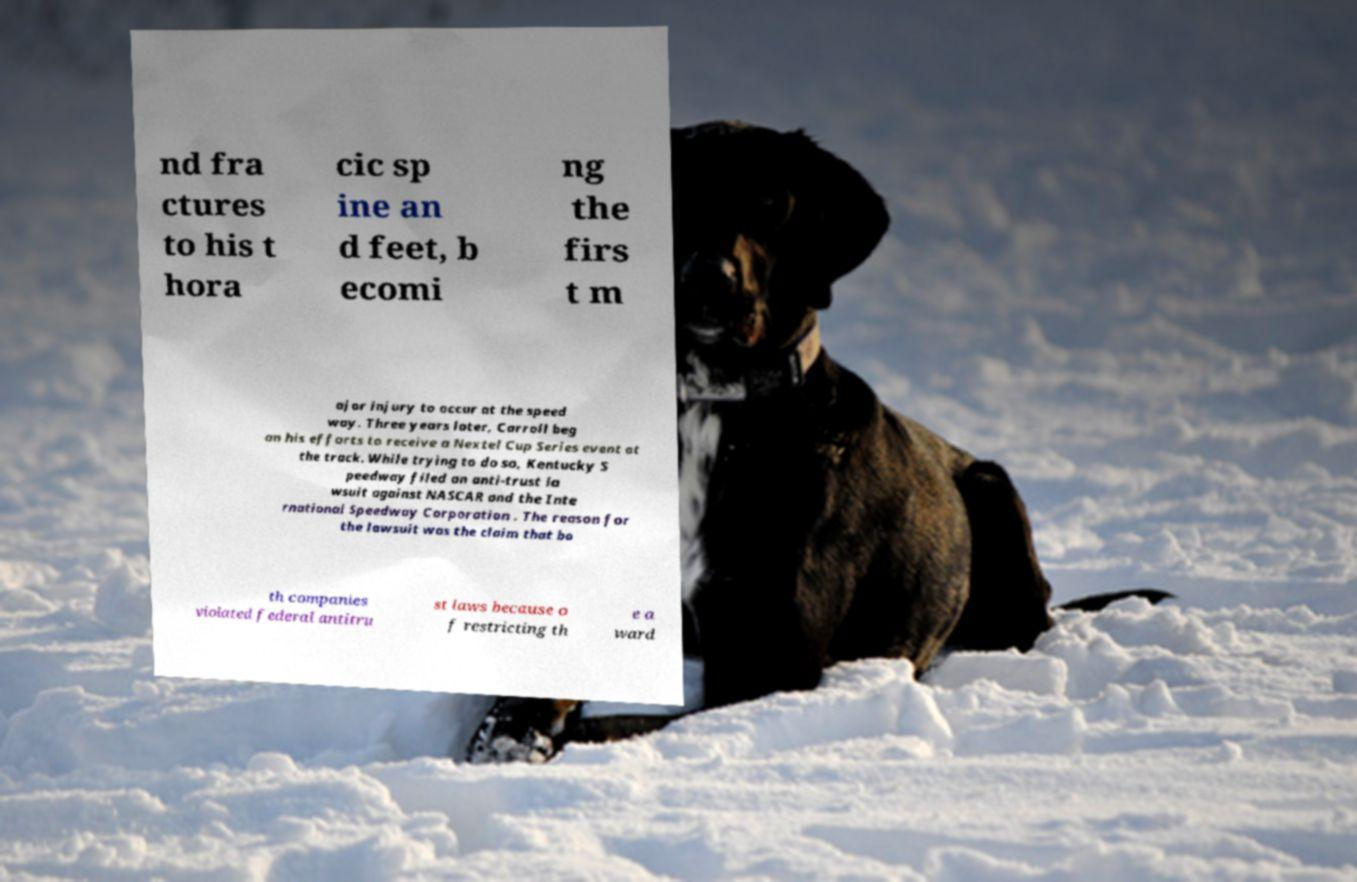For documentation purposes, I need the text within this image transcribed. Could you provide that? nd fra ctures to his t hora cic sp ine an d feet, b ecomi ng the firs t m ajor injury to occur at the speed way. Three years later, Carroll beg an his efforts to receive a Nextel Cup Series event at the track. While trying to do so, Kentucky S peedway filed an anti-trust la wsuit against NASCAR and the Inte rnational Speedway Corporation . The reason for the lawsuit was the claim that bo th companies violated federal antitru st laws because o f restricting th e a ward 